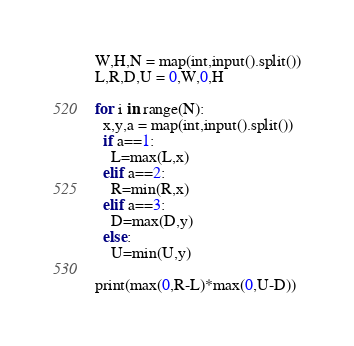<code> <loc_0><loc_0><loc_500><loc_500><_Python_>W,H,N = map(int,input().split())
L,R,D,U = 0,W,0,H

for i in range(N):
  x,y,a = map(int,input().split())
  if a==1:
    L=max(L,x)
  elif a==2:
    R=min(R,x)
  elif a==3:
    D=max(D,y)
  else:
    U=min(U,y)

print(max(0,R-L)*max(0,U-D))</code> 